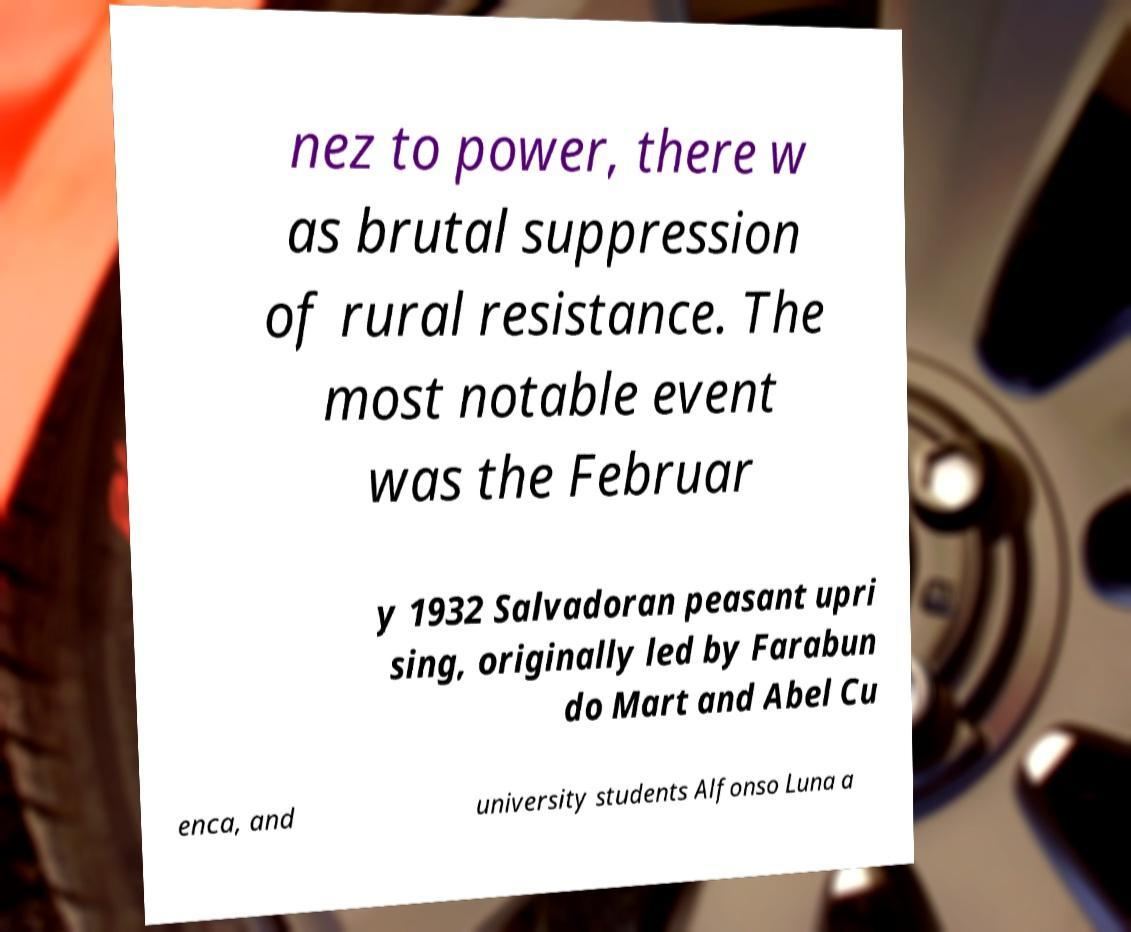Could you assist in decoding the text presented in this image and type it out clearly? nez to power, there w as brutal suppression of rural resistance. The most notable event was the Februar y 1932 Salvadoran peasant upri sing, originally led by Farabun do Mart and Abel Cu enca, and university students Alfonso Luna a 